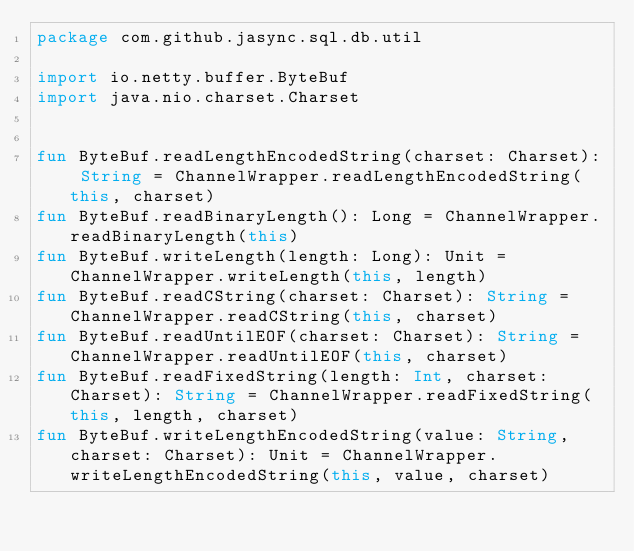Convert code to text. <code><loc_0><loc_0><loc_500><loc_500><_Kotlin_>package com.github.jasync.sql.db.util

import io.netty.buffer.ByteBuf
import java.nio.charset.Charset


fun ByteBuf.readLengthEncodedString(charset: Charset): String = ChannelWrapper.readLengthEncodedString(this, charset)
fun ByteBuf.readBinaryLength(): Long = ChannelWrapper.readBinaryLength(this)
fun ByteBuf.writeLength(length: Long): Unit = ChannelWrapper.writeLength(this, length)
fun ByteBuf.readCString(charset: Charset): String = ChannelWrapper.readCString(this, charset)
fun ByteBuf.readUntilEOF(charset: Charset): String = ChannelWrapper.readUntilEOF(this, charset)
fun ByteBuf.readFixedString(length: Int, charset: Charset): String = ChannelWrapper.readFixedString(this, length, charset)
fun ByteBuf.writeLengthEncodedString(value: String, charset: Charset): Unit = ChannelWrapper.writeLengthEncodedString(this, value, charset)

</code> 